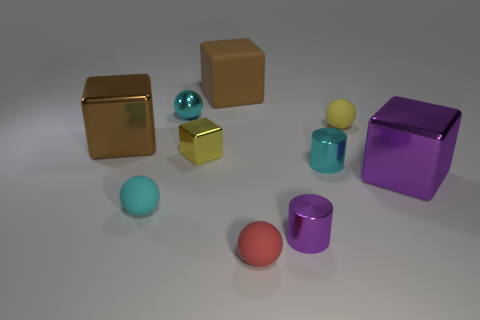Subtract 1 blocks. How many blocks are left? 3 Subtract all balls. How many objects are left? 6 Add 6 blocks. How many blocks exist? 10 Subtract 0 purple balls. How many objects are left? 10 Subtract all cyan matte objects. Subtract all cubes. How many objects are left? 5 Add 3 cyan things. How many cyan things are left? 6 